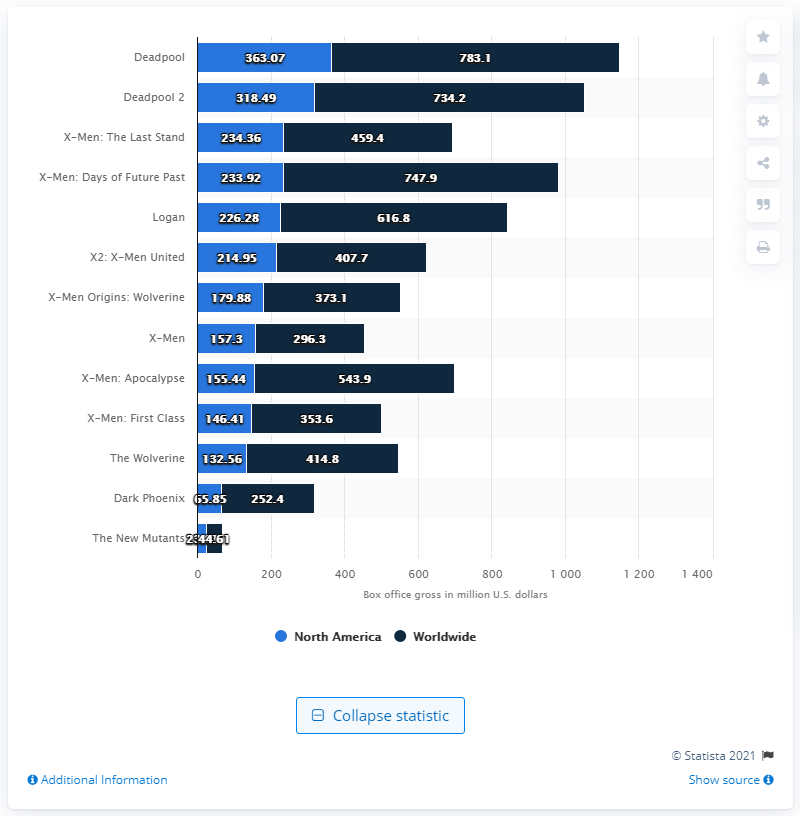Identify some key points in this picture. As of November 2020, the gross of 'The New Mutants' was 23.81. 